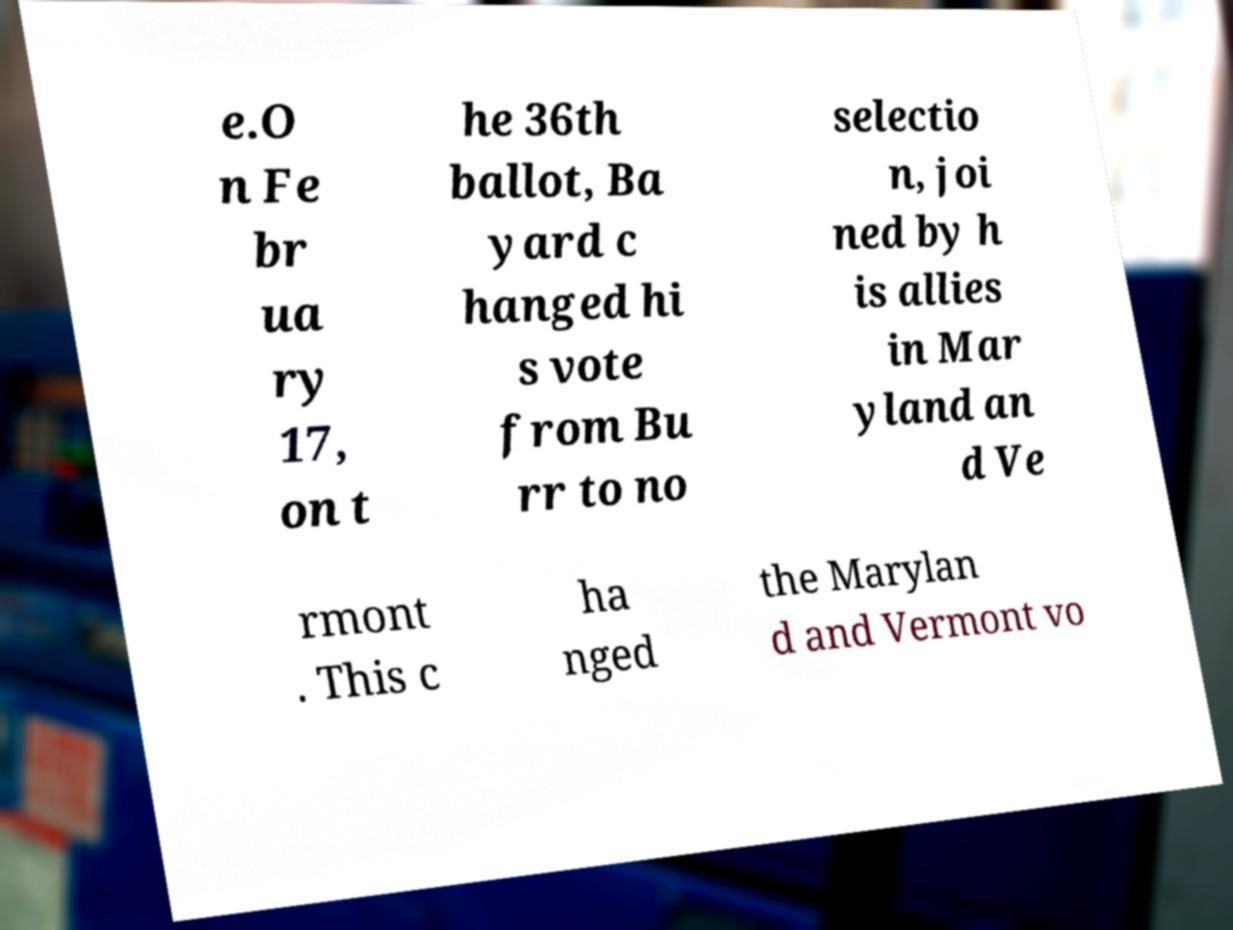I need the written content from this picture converted into text. Can you do that? e.O n Fe br ua ry 17, on t he 36th ballot, Ba yard c hanged hi s vote from Bu rr to no selectio n, joi ned by h is allies in Mar yland an d Ve rmont . This c ha nged the Marylan d and Vermont vo 